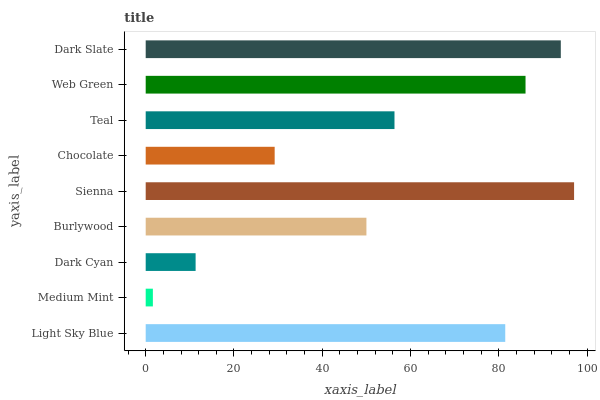Is Medium Mint the minimum?
Answer yes or no. Yes. Is Sienna the maximum?
Answer yes or no. Yes. Is Dark Cyan the minimum?
Answer yes or no. No. Is Dark Cyan the maximum?
Answer yes or no. No. Is Dark Cyan greater than Medium Mint?
Answer yes or no. Yes. Is Medium Mint less than Dark Cyan?
Answer yes or no. Yes. Is Medium Mint greater than Dark Cyan?
Answer yes or no. No. Is Dark Cyan less than Medium Mint?
Answer yes or no. No. Is Teal the high median?
Answer yes or no. Yes. Is Teal the low median?
Answer yes or no. Yes. Is Dark Cyan the high median?
Answer yes or no. No. Is Light Sky Blue the low median?
Answer yes or no. No. 